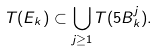Convert formula to latex. <formula><loc_0><loc_0><loc_500><loc_500>T ( E _ { k } ) \subset \bigcup _ { j \geq 1 } T ( 5 B _ { k } ^ { j } ) .</formula> 